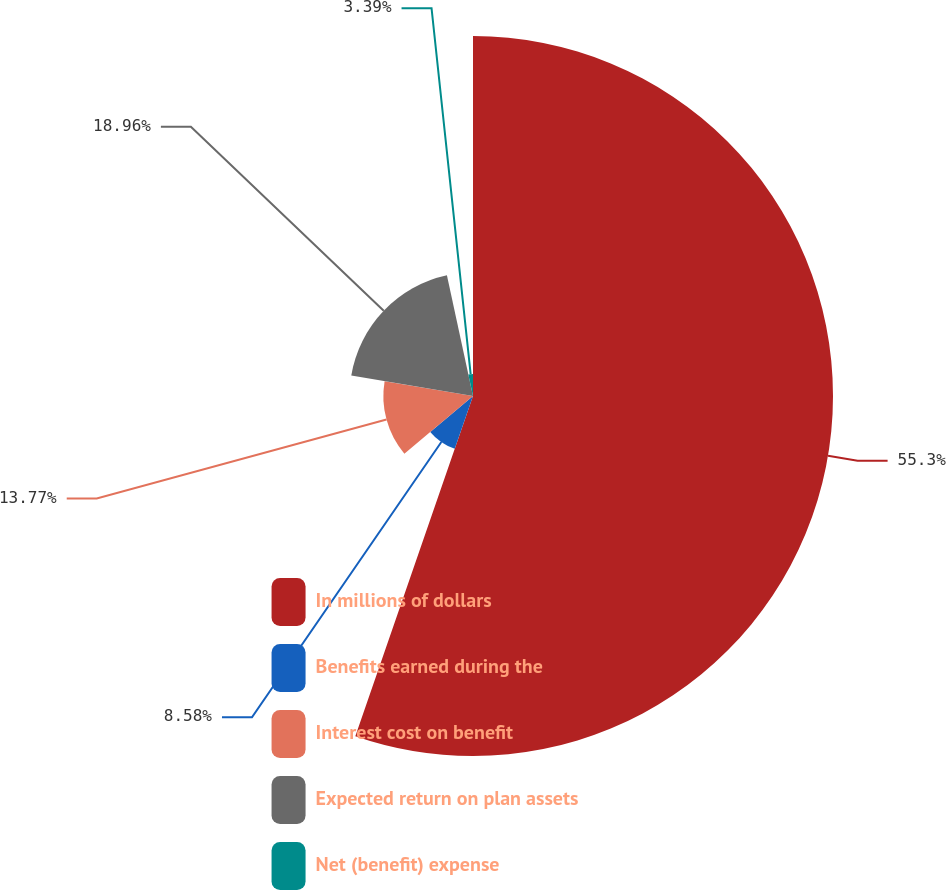<chart> <loc_0><loc_0><loc_500><loc_500><pie_chart><fcel>In millions of dollars<fcel>Benefits earned during the<fcel>Interest cost on benefit<fcel>Expected return on plan assets<fcel>Net (benefit) expense<nl><fcel>55.3%<fcel>8.58%<fcel>13.77%<fcel>18.96%<fcel>3.39%<nl></chart> 